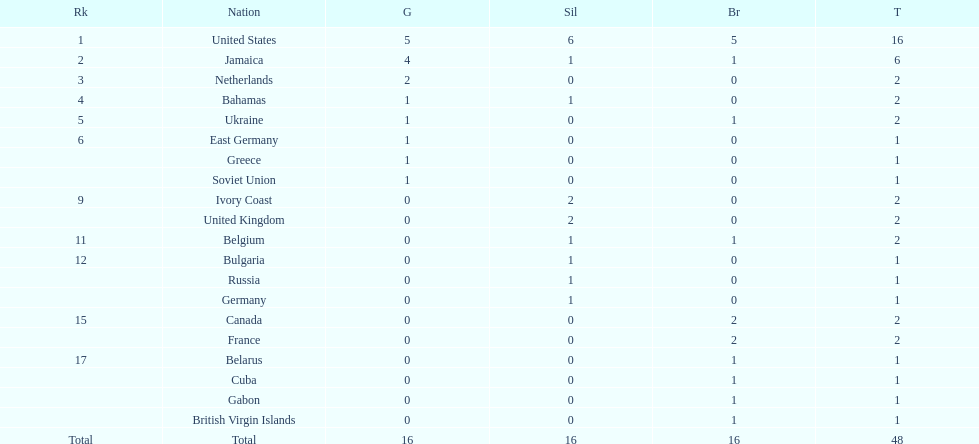How many nations won more than one silver medal? 3. 